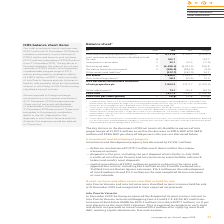According to Intu Properties's financial document, What is the net assets in 2019? According to the financial document, 1,846.0 (in millions). The relevant text states: "and liabilities 2 (307.7) (342.0) 34.3 Net assets 1,846.0 3,828.1 (1,982.1) Non-controlling interest 3 58.2 (16.4) 74.6 IFRS net assets attributable to owner..." Also, What is the EPRA NAV in 2018? According to the financial document, 3,947.1 (in millions). The relevant text states: "adjustments 4 73.1 135.4 (62.3) EPRA NAV 1,977.3 3,947.1 (1,969.8) EPRA NAV per share (pence) F 147p 293p (146)p..." Also, What is the change in EPRA NAV per share (pence) from 2018 to 2019? According to the financial document, (146). The relevant text states: "1 (1,969.8) EPRA NAV per share (pence) F 147p 293p (146)p..." Also, can you calculate: What is the percentage change in the total investment in joint ventures from 2018 to 2019? To answer this question, I need to perform calculations using the financial data. The calculation is: -299.8/(524.1+299.8), which equals -36.39 (percentage). This is based on the information: "to joint ventures £197.5 million), a decrease of £299.8 million from 31 December 2018. The key driver in the year related to the share of loss of joint ven items Our total investment in joint ventures..." The key data points involved are: 299.8, 524.1. Also, can you calculate: What is the percentage change in the EPRA NAV from 2018 to 2019? To answer this question, I need to perform calculations using the financial data. The calculation is: -(1,969.8/3,947.1), which equals -49.9 (percentage). This is based on the information: "adjustments 4 73.1 135.4 (62.3) EPRA NAV 1,977.3 3,947.1 (1,969.8) EPRA NAV per share (pence) F 147p 293p (146)p nts 4 73.1 135.4 (62.3) EPRA NAV 1,977.3 3,947.1 (1,969.8) EPRA NAV per share (pence) F..." The key data points involved are: 1,969.8, 3,947.1. Also, can you calculate: What is the percentage change in the IFRS net assets attributable to owners of intu properties plc from 2018 to 2019? To answer this question, I need to perform calculations using the financial data. The calculation is: -1,907.5/3,811.7, which equals -50.04 (percentage). This is based on the information: "to owners of intu properties plc 1,904.2 3,811.7 (1,907.5) ibutable to owners of intu properties plc 1,904.2 3,811.7 (1,907.5)..." The key data points involved are: 1,907.5, 3,811.7. 